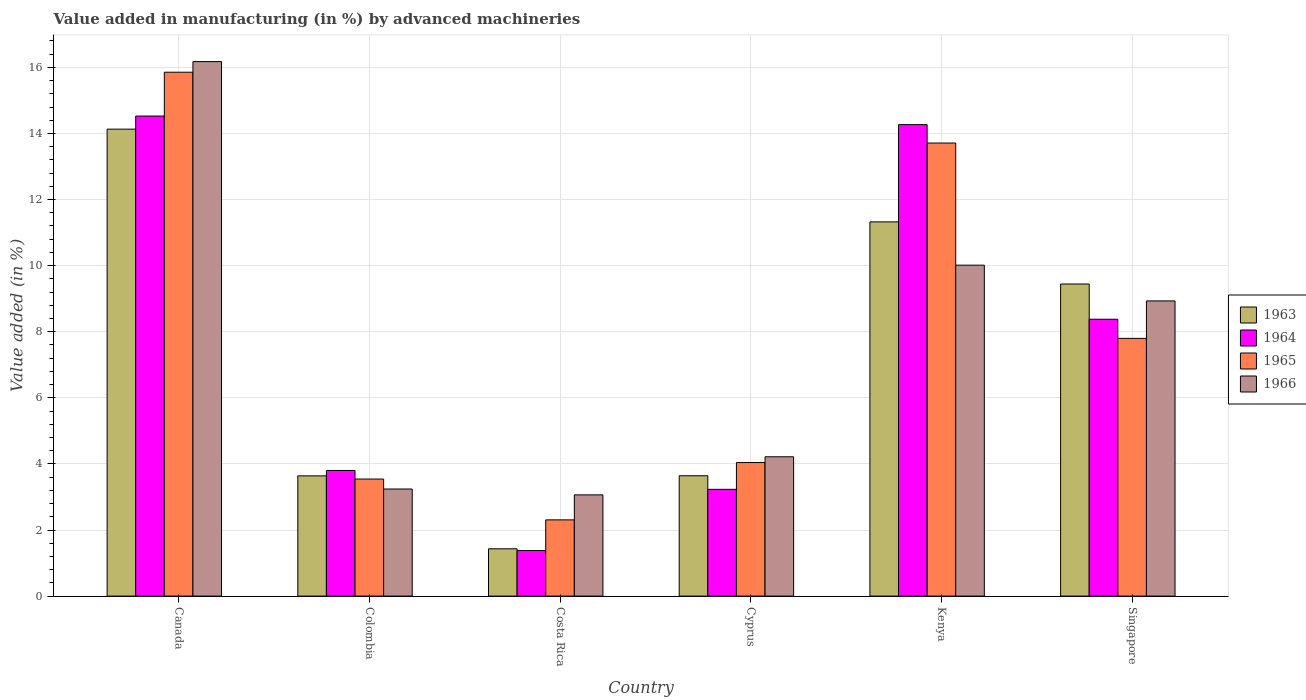How many groups of bars are there?
Offer a terse response. 6. Are the number of bars on each tick of the X-axis equal?
Make the answer very short. Yes. What is the label of the 5th group of bars from the left?
Keep it short and to the point. Kenya. In how many cases, is the number of bars for a given country not equal to the number of legend labels?
Your answer should be compact. 0. What is the percentage of value added in manufacturing by advanced machineries in 1963 in Canada?
Provide a succinct answer. 14.13. Across all countries, what is the maximum percentage of value added in manufacturing by advanced machineries in 1964?
Ensure brevity in your answer.  14.53. Across all countries, what is the minimum percentage of value added in manufacturing by advanced machineries in 1963?
Give a very brief answer. 1.43. In which country was the percentage of value added in manufacturing by advanced machineries in 1966 maximum?
Your response must be concise. Canada. In which country was the percentage of value added in manufacturing by advanced machineries in 1964 minimum?
Your answer should be compact. Costa Rica. What is the total percentage of value added in manufacturing by advanced machineries in 1965 in the graph?
Offer a terse response. 47.25. What is the difference between the percentage of value added in manufacturing by advanced machineries in 1966 in Colombia and that in Cyprus?
Ensure brevity in your answer.  -0.97. What is the difference between the percentage of value added in manufacturing by advanced machineries in 1963 in Singapore and the percentage of value added in manufacturing by advanced machineries in 1964 in Colombia?
Keep it short and to the point. 5.64. What is the average percentage of value added in manufacturing by advanced machineries in 1965 per country?
Make the answer very short. 7.88. What is the difference between the percentage of value added in manufacturing by advanced machineries of/in 1965 and percentage of value added in manufacturing by advanced machineries of/in 1964 in Costa Rica?
Ensure brevity in your answer.  0.93. What is the ratio of the percentage of value added in manufacturing by advanced machineries in 1963 in Costa Rica to that in Cyprus?
Your response must be concise. 0.39. What is the difference between the highest and the second highest percentage of value added in manufacturing by advanced machineries in 1966?
Provide a short and direct response. 7.24. What is the difference between the highest and the lowest percentage of value added in manufacturing by advanced machineries in 1966?
Your answer should be compact. 13.11. In how many countries, is the percentage of value added in manufacturing by advanced machineries in 1964 greater than the average percentage of value added in manufacturing by advanced machineries in 1964 taken over all countries?
Your answer should be compact. 3. Is the sum of the percentage of value added in manufacturing by advanced machineries in 1965 in Colombia and Kenya greater than the maximum percentage of value added in manufacturing by advanced machineries in 1963 across all countries?
Ensure brevity in your answer.  Yes. What does the 4th bar from the left in Singapore represents?
Offer a terse response. 1966. What does the 2nd bar from the right in Colombia represents?
Your answer should be very brief. 1965. Is it the case that in every country, the sum of the percentage of value added in manufacturing by advanced machineries in 1963 and percentage of value added in manufacturing by advanced machineries in 1966 is greater than the percentage of value added in manufacturing by advanced machineries in 1965?
Make the answer very short. Yes. How many bars are there?
Make the answer very short. 24. How many countries are there in the graph?
Offer a terse response. 6. Does the graph contain any zero values?
Ensure brevity in your answer.  No. Does the graph contain grids?
Offer a terse response. Yes. How many legend labels are there?
Make the answer very short. 4. What is the title of the graph?
Provide a short and direct response. Value added in manufacturing (in %) by advanced machineries. Does "1972" appear as one of the legend labels in the graph?
Offer a very short reply. No. What is the label or title of the X-axis?
Make the answer very short. Country. What is the label or title of the Y-axis?
Ensure brevity in your answer.  Value added (in %). What is the Value added (in %) of 1963 in Canada?
Provide a short and direct response. 14.13. What is the Value added (in %) in 1964 in Canada?
Your response must be concise. 14.53. What is the Value added (in %) of 1965 in Canada?
Offer a very short reply. 15.85. What is the Value added (in %) in 1966 in Canada?
Give a very brief answer. 16.17. What is the Value added (in %) of 1963 in Colombia?
Your answer should be very brief. 3.64. What is the Value added (in %) in 1964 in Colombia?
Keep it short and to the point. 3.8. What is the Value added (in %) in 1965 in Colombia?
Keep it short and to the point. 3.54. What is the Value added (in %) of 1966 in Colombia?
Your response must be concise. 3.24. What is the Value added (in %) of 1963 in Costa Rica?
Make the answer very short. 1.43. What is the Value added (in %) in 1964 in Costa Rica?
Keep it short and to the point. 1.38. What is the Value added (in %) in 1965 in Costa Rica?
Make the answer very short. 2.31. What is the Value added (in %) in 1966 in Costa Rica?
Ensure brevity in your answer.  3.06. What is the Value added (in %) in 1963 in Cyprus?
Offer a terse response. 3.64. What is the Value added (in %) in 1964 in Cyprus?
Keep it short and to the point. 3.23. What is the Value added (in %) in 1965 in Cyprus?
Make the answer very short. 4.04. What is the Value added (in %) in 1966 in Cyprus?
Keep it short and to the point. 4.22. What is the Value added (in %) in 1963 in Kenya?
Ensure brevity in your answer.  11.32. What is the Value added (in %) in 1964 in Kenya?
Provide a succinct answer. 14.27. What is the Value added (in %) of 1965 in Kenya?
Offer a terse response. 13.71. What is the Value added (in %) of 1966 in Kenya?
Give a very brief answer. 10.01. What is the Value added (in %) in 1963 in Singapore?
Your answer should be very brief. 9.44. What is the Value added (in %) in 1964 in Singapore?
Keep it short and to the point. 8.38. What is the Value added (in %) in 1965 in Singapore?
Provide a short and direct response. 7.8. What is the Value added (in %) of 1966 in Singapore?
Your response must be concise. 8.93. Across all countries, what is the maximum Value added (in %) in 1963?
Ensure brevity in your answer.  14.13. Across all countries, what is the maximum Value added (in %) of 1964?
Your answer should be very brief. 14.53. Across all countries, what is the maximum Value added (in %) in 1965?
Your response must be concise. 15.85. Across all countries, what is the maximum Value added (in %) in 1966?
Provide a succinct answer. 16.17. Across all countries, what is the minimum Value added (in %) in 1963?
Your answer should be compact. 1.43. Across all countries, what is the minimum Value added (in %) of 1964?
Your answer should be compact. 1.38. Across all countries, what is the minimum Value added (in %) in 1965?
Make the answer very short. 2.31. Across all countries, what is the minimum Value added (in %) in 1966?
Your answer should be compact. 3.06. What is the total Value added (in %) of 1963 in the graph?
Keep it short and to the point. 43.61. What is the total Value added (in %) in 1964 in the graph?
Offer a very short reply. 45.58. What is the total Value added (in %) of 1965 in the graph?
Keep it short and to the point. 47.25. What is the total Value added (in %) of 1966 in the graph?
Your answer should be very brief. 45.64. What is the difference between the Value added (in %) of 1963 in Canada and that in Colombia?
Keep it short and to the point. 10.49. What is the difference between the Value added (in %) of 1964 in Canada and that in Colombia?
Make the answer very short. 10.72. What is the difference between the Value added (in %) in 1965 in Canada and that in Colombia?
Your answer should be compact. 12.31. What is the difference between the Value added (in %) of 1966 in Canada and that in Colombia?
Provide a succinct answer. 12.93. What is the difference between the Value added (in %) of 1963 in Canada and that in Costa Rica?
Give a very brief answer. 12.7. What is the difference between the Value added (in %) in 1964 in Canada and that in Costa Rica?
Provide a succinct answer. 13.15. What is the difference between the Value added (in %) of 1965 in Canada and that in Costa Rica?
Your answer should be very brief. 13.55. What is the difference between the Value added (in %) of 1966 in Canada and that in Costa Rica?
Make the answer very short. 13.11. What is the difference between the Value added (in %) in 1963 in Canada and that in Cyprus?
Your answer should be very brief. 10.49. What is the difference between the Value added (in %) of 1964 in Canada and that in Cyprus?
Offer a very short reply. 11.3. What is the difference between the Value added (in %) in 1965 in Canada and that in Cyprus?
Your answer should be very brief. 11.81. What is the difference between the Value added (in %) in 1966 in Canada and that in Cyprus?
Give a very brief answer. 11.96. What is the difference between the Value added (in %) in 1963 in Canada and that in Kenya?
Ensure brevity in your answer.  2.81. What is the difference between the Value added (in %) in 1964 in Canada and that in Kenya?
Provide a succinct answer. 0.26. What is the difference between the Value added (in %) in 1965 in Canada and that in Kenya?
Offer a terse response. 2.14. What is the difference between the Value added (in %) in 1966 in Canada and that in Kenya?
Keep it short and to the point. 6.16. What is the difference between the Value added (in %) in 1963 in Canada and that in Singapore?
Your answer should be very brief. 4.69. What is the difference between the Value added (in %) of 1964 in Canada and that in Singapore?
Make the answer very short. 6.15. What is the difference between the Value added (in %) in 1965 in Canada and that in Singapore?
Make the answer very short. 8.05. What is the difference between the Value added (in %) of 1966 in Canada and that in Singapore?
Your answer should be very brief. 7.24. What is the difference between the Value added (in %) in 1963 in Colombia and that in Costa Rica?
Your response must be concise. 2.21. What is the difference between the Value added (in %) of 1964 in Colombia and that in Costa Rica?
Ensure brevity in your answer.  2.42. What is the difference between the Value added (in %) of 1965 in Colombia and that in Costa Rica?
Your answer should be compact. 1.24. What is the difference between the Value added (in %) of 1966 in Colombia and that in Costa Rica?
Give a very brief answer. 0.18. What is the difference between the Value added (in %) of 1963 in Colombia and that in Cyprus?
Make the answer very short. -0. What is the difference between the Value added (in %) in 1964 in Colombia and that in Cyprus?
Offer a terse response. 0.57. What is the difference between the Value added (in %) of 1965 in Colombia and that in Cyprus?
Provide a succinct answer. -0.5. What is the difference between the Value added (in %) in 1966 in Colombia and that in Cyprus?
Provide a succinct answer. -0.97. What is the difference between the Value added (in %) in 1963 in Colombia and that in Kenya?
Give a very brief answer. -7.69. What is the difference between the Value added (in %) of 1964 in Colombia and that in Kenya?
Give a very brief answer. -10.47. What is the difference between the Value added (in %) of 1965 in Colombia and that in Kenya?
Offer a terse response. -10.17. What is the difference between the Value added (in %) in 1966 in Colombia and that in Kenya?
Your response must be concise. -6.77. What is the difference between the Value added (in %) of 1963 in Colombia and that in Singapore?
Provide a succinct answer. -5.81. What is the difference between the Value added (in %) of 1964 in Colombia and that in Singapore?
Keep it short and to the point. -4.58. What is the difference between the Value added (in %) of 1965 in Colombia and that in Singapore?
Make the answer very short. -4.26. What is the difference between the Value added (in %) of 1966 in Colombia and that in Singapore?
Provide a short and direct response. -5.69. What is the difference between the Value added (in %) of 1963 in Costa Rica and that in Cyprus?
Make the answer very short. -2.21. What is the difference between the Value added (in %) in 1964 in Costa Rica and that in Cyprus?
Give a very brief answer. -1.85. What is the difference between the Value added (in %) in 1965 in Costa Rica and that in Cyprus?
Your answer should be compact. -1.73. What is the difference between the Value added (in %) of 1966 in Costa Rica and that in Cyprus?
Give a very brief answer. -1.15. What is the difference between the Value added (in %) of 1963 in Costa Rica and that in Kenya?
Ensure brevity in your answer.  -9.89. What is the difference between the Value added (in %) in 1964 in Costa Rica and that in Kenya?
Offer a terse response. -12.89. What is the difference between the Value added (in %) of 1965 in Costa Rica and that in Kenya?
Offer a terse response. -11.4. What is the difference between the Value added (in %) of 1966 in Costa Rica and that in Kenya?
Your answer should be compact. -6.95. What is the difference between the Value added (in %) in 1963 in Costa Rica and that in Singapore?
Keep it short and to the point. -8.01. What is the difference between the Value added (in %) of 1964 in Costa Rica and that in Singapore?
Make the answer very short. -7. What is the difference between the Value added (in %) of 1965 in Costa Rica and that in Singapore?
Your answer should be compact. -5.49. What is the difference between the Value added (in %) of 1966 in Costa Rica and that in Singapore?
Offer a terse response. -5.87. What is the difference between the Value added (in %) of 1963 in Cyprus and that in Kenya?
Make the answer very short. -7.68. What is the difference between the Value added (in %) of 1964 in Cyprus and that in Kenya?
Give a very brief answer. -11.04. What is the difference between the Value added (in %) of 1965 in Cyprus and that in Kenya?
Keep it short and to the point. -9.67. What is the difference between the Value added (in %) of 1966 in Cyprus and that in Kenya?
Keep it short and to the point. -5.8. What is the difference between the Value added (in %) in 1963 in Cyprus and that in Singapore?
Offer a very short reply. -5.8. What is the difference between the Value added (in %) of 1964 in Cyprus and that in Singapore?
Ensure brevity in your answer.  -5.15. What is the difference between the Value added (in %) of 1965 in Cyprus and that in Singapore?
Your response must be concise. -3.76. What is the difference between the Value added (in %) of 1966 in Cyprus and that in Singapore?
Provide a short and direct response. -4.72. What is the difference between the Value added (in %) of 1963 in Kenya and that in Singapore?
Your response must be concise. 1.88. What is the difference between the Value added (in %) of 1964 in Kenya and that in Singapore?
Give a very brief answer. 5.89. What is the difference between the Value added (in %) in 1965 in Kenya and that in Singapore?
Give a very brief answer. 5.91. What is the difference between the Value added (in %) in 1966 in Kenya and that in Singapore?
Make the answer very short. 1.08. What is the difference between the Value added (in %) in 1963 in Canada and the Value added (in %) in 1964 in Colombia?
Offer a terse response. 10.33. What is the difference between the Value added (in %) of 1963 in Canada and the Value added (in %) of 1965 in Colombia?
Make the answer very short. 10.59. What is the difference between the Value added (in %) of 1963 in Canada and the Value added (in %) of 1966 in Colombia?
Provide a succinct answer. 10.89. What is the difference between the Value added (in %) of 1964 in Canada and the Value added (in %) of 1965 in Colombia?
Keep it short and to the point. 10.98. What is the difference between the Value added (in %) of 1964 in Canada and the Value added (in %) of 1966 in Colombia?
Your answer should be very brief. 11.29. What is the difference between the Value added (in %) of 1965 in Canada and the Value added (in %) of 1966 in Colombia?
Your answer should be very brief. 12.61. What is the difference between the Value added (in %) of 1963 in Canada and the Value added (in %) of 1964 in Costa Rica?
Ensure brevity in your answer.  12.75. What is the difference between the Value added (in %) of 1963 in Canada and the Value added (in %) of 1965 in Costa Rica?
Give a very brief answer. 11.82. What is the difference between the Value added (in %) of 1963 in Canada and the Value added (in %) of 1966 in Costa Rica?
Give a very brief answer. 11.07. What is the difference between the Value added (in %) in 1964 in Canada and the Value added (in %) in 1965 in Costa Rica?
Keep it short and to the point. 12.22. What is the difference between the Value added (in %) of 1964 in Canada and the Value added (in %) of 1966 in Costa Rica?
Keep it short and to the point. 11.46. What is the difference between the Value added (in %) of 1965 in Canada and the Value added (in %) of 1966 in Costa Rica?
Make the answer very short. 12.79. What is the difference between the Value added (in %) of 1963 in Canada and the Value added (in %) of 1964 in Cyprus?
Your answer should be very brief. 10.9. What is the difference between the Value added (in %) in 1963 in Canada and the Value added (in %) in 1965 in Cyprus?
Give a very brief answer. 10.09. What is the difference between the Value added (in %) in 1963 in Canada and the Value added (in %) in 1966 in Cyprus?
Make the answer very short. 9.92. What is the difference between the Value added (in %) of 1964 in Canada and the Value added (in %) of 1965 in Cyprus?
Provide a short and direct response. 10.49. What is the difference between the Value added (in %) of 1964 in Canada and the Value added (in %) of 1966 in Cyprus?
Provide a short and direct response. 10.31. What is the difference between the Value added (in %) in 1965 in Canada and the Value added (in %) in 1966 in Cyprus?
Provide a short and direct response. 11.64. What is the difference between the Value added (in %) in 1963 in Canada and the Value added (in %) in 1964 in Kenya?
Ensure brevity in your answer.  -0.14. What is the difference between the Value added (in %) of 1963 in Canada and the Value added (in %) of 1965 in Kenya?
Provide a short and direct response. 0.42. What is the difference between the Value added (in %) in 1963 in Canada and the Value added (in %) in 1966 in Kenya?
Keep it short and to the point. 4.12. What is the difference between the Value added (in %) of 1964 in Canada and the Value added (in %) of 1965 in Kenya?
Ensure brevity in your answer.  0.82. What is the difference between the Value added (in %) in 1964 in Canada and the Value added (in %) in 1966 in Kenya?
Your response must be concise. 4.51. What is the difference between the Value added (in %) of 1965 in Canada and the Value added (in %) of 1966 in Kenya?
Offer a very short reply. 5.84. What is the difference between the Value added (in %) of 1963 in Canada and the Value added (in %) of 1964 in Singapore?
Make the answer very short. 5.75. What is the difference between the Value added (in %) in 1963 in Canada and the Value added (in %) in 1965 in Singapore?
Keep it short and to the point. 6.33. What is the difference between the Value added (in %) of 1963 in Canada and the Value added (in %) of 1966 in Singapore?
Your answer should be very brief. 5.2. What is the difference between the Value added (in %) in 1964 in Canada and the Value added (in %) in 1965 in Singapore?
Provide a succinct answer. 6.73. What is the difference between the Value added (in %) in 1964 in Canada and the Value added (in %) in 1966 in Singapore?
Your answer should be very brief. 5.59. What is the difference between the Value added (in %) of 1965 in Canada and the Value added (in %) of 1966 in Singapore?
Your response must be concise. 6.92. What is the difference between the Value added (in %) in 1963 in Colombia and the Value added (in %) in 1964 in Costa Rica?
Provide a short and direct response. 2.26. What is the difference between the Value added (in %) of 1963 in Colombia and the Value added (in %) of 1965 in Costa Rica?
Provide a succinct answer. 1.33. What is the difference between the Value added (in %) of 1963 in Colombia and the Value added (in %) of 1966 in Costa Rica?
Your answer should be compact. 0.57. What is the difference between the Value added (in %) in 1964 in Colombia and the Value added (in %) in 1965 in Costa Rica?
Ensure brevity in your answer.  1.49. What is the difference between the Value added (in %) of 1964 in Colombia and the Value added (in %) of 1966 in Costa Rica?
Your response must be concise. 0.74. What is the difference between the Value added (in %) in 1965 in Colombia and the Value added (in %) in 1966 in Costa Rica?
Offer a very short reply. 0.48. What is the difference between the Value added (in %) in 1963 in Colombia and the Value added (in %) in 1964 in Cyprus?
Provide a succinct answer. 0.41. What is the difference between the Value added (in %) of 1963 in Colombia and the Value added (in %) of 1965 in Cyprus?
Provide a short and direct response. -0.4. What is the difference between the Value added (in %) in 1963 in Colombia and the Value added (in %) in 1966 in Cyprus?
Your answer should be compact. -0.58. What is the difference between the Value added (in %) of 1964 in Colombia and the Value added (in %) of 1965 in Cyprus?
Your answer should be very brief. -0.24. What is the difference between the Value added (in %) in 1964 in Colombia and the Value added (in %) in 1966 in Cyprus?
Provide a succinct answer. -0.41. What is the difference between the Value added (in %) in 1965 in Colombia and the Value added (in %) in 1966 in Cyprus?
Your answer should be compact. -0.67. What is the difference between the Value added (in %) of 1963 in Colombia and the Value added (in %) of 1964 in Kenya?
Your response must be concise. -10.63. What is the difference between the Value added (in %) in 1963 in Colombia and the Value added (in %) in 1965 in Kenya?
Provide a short and direct response. -10.07. What is the difference between the Value added (in %) in 1963 in Colombia and the Value added (in %) in 1966 in Kenya?
Keep it short and to the point. -6.38. What is the difference between the Value added (in %) of 1964 in Colombia and the Value added (in %) of 1965 in Kenya?
Make the answer very short. -9.91. What is the difference between the Value added (in %) in 1964 in Colombia and the Value added (in %) in 1966 in Kenya?
Provide a succinct answer. -6.21. What is the difference between the Value added (in %) in 1965 in Colombia and the Value added (in %) in 1966 in Kenya?
Offer a very short reply. -6.47. What is the difference between the Value added (in %) of 1963 in Colombia and the Value added (in %) of 1964 in Singapore?
Give a very brief answer. -4.74. What is the difference between the Value added (in %) of 1963 in Colombia and the Value added (in %) of 1965 in Singapore?
Your response must be concise. -4.16. What is the difference between the Value added (in %) in 1963 in Colombia and the Value added (in %) in 1966 in Singapore?
Provide a short and direct response. -5.29. What is the difference between the Value added (in %) of 1964 in Colombia and the Value added (in %) of 1965 in Singapore?
Give a very brief answer. -4. What is the difference between the Value added (in %) in 1964 in Colombia and the Value added (in %) in 1966 in Singapore?
Provide a short and direct response. -5.13. What is the difference between the Value added (in %) of 1965 in Colombia and the Value added (in %) of 1966 in Singapore?
Your answer should be compact. -5.39. What is the difference between the Value added (in %) of 1963 in Costa Rica and the Value added (in %) of 1964 in Cyprus?
Provide a short and direct response. -1.8. What is the difference between the Value added (in %) in 1963 in Costa Rica and the Value added (in %) in 1965 in Cyprus?
Provide a short and direct response. -2.61. What is the difference between the Value added (in %) of 1963 in Costa Rica and the Value added (in %) of 1966 in Cyprus?
Ensure brevity in your answer.  -2.78. What is the difference between the Value added (in %) of 1964 in Costa Rica and the Value added (in %) of 1965 in Cyprus?
Offer a terse response. -2.66. What is the difference between the Value added (in %) in 1964 in Costa Rica and the Value added (in %) in 1966 in Cyprus?
Keep it short and to the point. -2.84. What is the difference between the Value added (in %) of 1965 in Costa Rica and the Value added (in %) of 1966 in Cyprus?
Keep it short and to the point. -1.91. What is the difference between the Value added (in %) in 1963 in Costa Rica and the Value added (in %) in 1964 in Kenya?
Offer a very short reply. -12.84. What is the difference between the Value added (in %) in 1963 in Costa Rica and the Value added (in %) in 1965 in Kenya?
Ensure brevity in your answer.  -12.28. What is the difference between the Value added (in %) of 1963 in Costa Rica and the Value added (in %) of 1966 in Kenya?
Provide a short and direct response. -8.58. What is the difference between the Value added (in %) of 1964 in Costa Rica and the Value added (in %) of 1965 in Kenya?
Your response must be concise. -12.33. What is the difference between the Value added (in %) in 1964 in Costa Rica and the Value added (in %) in 1966 in Kenya?
Provide a succinct answer. -8.64. What is the difference between the Value added (in %) of 1965 in Costa Rica and the Value added (in %) of 1966 in Kenya?
Offer a terse response. -7.71. What is the difference between the Value added (in %) in 1963 in Costa Rica and the Value added (in %) in 1964 in Singapore?
Provide a succinct answer. -6.95. What is the difference between the Value added (in %) in 1963 in Costa Rica and the Value added (in %) in 1965 in Singapore?
Provide a short and direct response. -6.37. What is the difference between the Value added (in %) in 1963 in Costa Rica and the Value added (in %) in 1966 in Singapore?
Offer a terse response. -7.5. What is the difference between the Value added (in %) of 1964 in Costa Rica and the Value added (in %) of 1965 in Singapore?
Keep it short and to the point. -6.42. What is the difference between the Value added (in %) in 1964 in Costa Rica and the Value added (in %) in 1966 in Singapore?
Provide a short and direct response. -7.55. What is the difference between the Value added (in %) in 1965 in Costa Rica and the Value added (in %) in 1966 in Singapore?
Keep it short and to the point. -6.63. What is the difference between the Value added (in %) of 1963 in Cyprus and the Value added (in %) of 1964 in Kenya?
Your response must be concise. -10.63. What is the difference between the Value added (in %) of 1963 in Cyprus and the Value added (in %) of 1965 in Kenya?
Your response must be concise. -10.07. What is the difference between the Value added (in %) of 1963 in Cyprus and the Value added (in %) of 1966 in Kenya?
Your answer should be compact. -6.37. What is the difference between the Value added (in %) of 1964 in Cyprus and the Value added (in %) of 1965 in Kenya?
Your response must be concise. -10.48. What is the difference between the Value added (in %) of 1964 in Cyprus and the Value added (in %) of 1966 in Kenya?
Offer a very short reply. -6.78. What is the difference between the Value added (in %) in 1965 in Cyprus and the Value added (in %) in 1966 in Kenya?
Your answer should be very brief. -5.97. What is the difference between the Value added (in %) of 1963 in Cyprus and the Value added (in %) of 1964 in Singapore?
Keep it short and to the point. -4.74. What is the difference between the Value added (in %) in 1963 in Cyprus and the Value added (in %) in 1965 in Singapore?
Ensure brevity in your answer.  -4.16. What is the difference between the Value added (in %) of 1963 in Cyprus and the Value added (in %) of 1966 in Singapore?
Offer a terse response. -5.29. What is the difference between the Value added (in %) of 1964 in Cyprus and the Value added (in %) of 1965 in Singapore?
Keep it short and to the point. -4.57. What is the difference between the Value added (in %) of 1964 in Cyprus and the Value added (in %) of 1966 in Singapore?
Provide a succinct answer. -5.7. What is the difference between the Value added (in %) of 1965 in Cyprus and the Value added (in %) of 1966 in Singapore?
Your answer should be very brief. -4.89. What is the difference between the Value added (in %) of 1963 in Kenya and the Value added (in %) of 1964 in Singapore?
Your answer should be compact. 2.95. What is the difference between the Value added (in %) of 1963 in Kenya and the Value added (in %) of 1965 in Singapore?
Keep it short and to the point. 3.52. What is the difference between the Value added (in %) of 1963 in Kenya and the Value added (in %) of 1966 in Singapore?
Ensure brevity in your answer.  2.39. What is the difference between the Value added (in %) of 1964 in Kenya and the Value added (in %) of 1965 in Singapore?
Your answer should be very brief. 6.47. What is the difference between the Value added (in %) of 1964 in Kenya and the Value added (in %) of 1966 in Singapore?
Make the answer very short. 5.33. What is the difference between the Value added (in %) in 1965 in Kenya and the Value added (in %) in 1966 in Singapore?
Your response must be concise. 4.78. What is the average Value added (in %) of 1963 per country?
Provide a short and direct response. 7.27. What is the average Value added (in %) in 1964 per country?
Give a very brief answer. 7.6. What is the average Value added (in %) in 1965 per country?
Make the answer very short. 7.88. What is the average Value added (in %) of 1966 per country?
Keep it short and to the point. 7.61. What is the difference between the Value added (in %) of 1963 and Value added (in %) of 1964 in Canada?
Provide a succinct answer. -0.4. What is the difference between the Value added (in %) in 1963 and Value added (in %) in 1965 in Canada?
Your answer should be very brief. -1.72. What is the difference between the Value added (in %) in 1963 and Value added (in %) in 1966 in Canada?
Your answer should be very brief. -2.04. What is the difference between the Value added (in %) in 1964 and Value added (in %) in 1965 in Canada?
Make the answer very short. -1.33. What is the difference between the Value added (in %) of 1964 and Value added (in %) of 1966 in Canada?
Your answer should be compact. -1.65. What is the difference between the Value added (in %) of 1965 and Value added (in %) of 1966 in Canada?
Your answer should be very brief. -0.32. What is the difference between the Value added (in %) in 1963 and Value added (in %) in 1964 in Colombia?
Offer a terse response. -0.16. What is the difference between the Value added (in %) of 1963 and Value added (in %) of 1965 in Colombia?
Give a very brief answer. 0.1. What is the difference between the Value added (in %) of 1963 and Value added (in %) of 1966 in Colombia?
Keep it short and to the point. 0.4. What is the difference between the Value added (in %) of 1964 and Value added (in %) of 1965 in Colombia?
Your response must be concise. 0.26. What is the difference between the Value added (in %) of 1964 and Value added (in %) of 1966 in Colombia?
Your response must be concise. 0.56. What is the difference between the Value added (in %) in 1965 and Value added (in %) in 1966 in Colombia?
Offer a terse response. 0.3. What is the difference between the Value added (in %) in 1963 and Value added (in %) in 1964 in Costa Rica?
Provide a succinct answer. 0.05. What is the difference between the Value added (in %) of 1963 and Value added (in %) of 1965 in Costa Rica?
Offer a very short reply. -0.88. What is the difference between the Value added (in %) in 1963 and Value added (in %) in 1966 in Costa Rica?
Ensure brevity in your answer.  -1.63. What is the difference between the Value added (in %) in 1964 and Value added (in %) in 1965 in Costa Rica?
Offer a very short reply. -0.93. What is the difference between the Value added (in %) in 1964 and Value added (in %) in 1966 in Costa Rica?
Your answer should be very brief. -1.69. What is the difference between the Value added (in %) in 1965 and Value added (in %) in 1966 in Costa Rica?
Make the answer very short. -0.76. What is the difference between the Value added (in %) of 1963 and Value added (in %) of 1964 in Cyprus?
Offer a very short reply. 0.41. What is the difference between the Value added (in %) in 1963 and Value added (in %) in 1965 in Cyprus?
Ensure brevity in your answer.  -0.4. What is the difference between the Value added (in %) in 1963 and Value added (in %) in 1966 in Cyprus?
Your answer should be very brief. -0.57. What is the difference between the Value added (in %) of 1964 and Value added (in %) of 1965 in Cyprus?
Offer a terse response. -0.81. What is the difference between the Value added (in %) in 1964 and Value added (in %) in 1966 in Cyprus?
Your answer should be compact. -0.98. What is the difference between the Value added (in %) in 1965 and Value added (in %) in 1966 in Cyprus?
Give a very brief answer. -0.17. What is the difference between the Value added (in %) in 1963 and Value added (in %) in 1964 in Kenya?
Give a very brief answer. -2.94. What is the difference between the Value added (in %) in 1963 and Value added (in %) in 1965 in Kenya?
Your answer should be compact. -2.39. What is the difference between the Value added (in %) of 1963 and Value added (in %) of 1966 in Kenya?
Offer a terse response. 1.31. What is the difference between the Value added (in %) in 1964 and Value added (in %) in 1965 in Kenya?
Ensure brevity in your answer.  0.56. What is the difference between the Value added (in %) of 1964 and Value added (in %) of 1966 in Kenya?
Provide a succinct answer. 4.25. What is the difference between the Value added (in %) of 1965 and Value added (in %) of 1966 in Kenya?
Make the answer very short. 3.7. What is the difference between the Value added (in %) of 1963 and Value added (in %) of 1964 in Singapore?
Your answer should be compact. 1.07. What is the difference between the Value added (in %) in 1963 and Value added (in %) in 1965 in Singapore?
Offer a very short reply. 1.64. What is the difference between the Value added (in %) of 1963 and Value added (in %) of 1966 in Singapore?
Give a very brief answer. 0.51. What is the difference between the Value added (in %) in 1964 and Value added (in %) in 1965 in Singapore?
Keep it short and to the point. 0.58. What is the difference between the Value added (in %) in 1964 and Value added (in %) in 1966 in Singapore?
Make the answer very short. -0.55. What is the difference between the Value added (in %) in 1965 and Value added (in %) in 1966 in Singapore?
Provide a succinct answer. -1.13. What is the ratio of the Value added (in %) of 1963 in Canada to that in Colombia?
Offer a terse response. 3.88. What is the ratio of the Value added (in %) of 1964 in Canada to that in Colombia?
Make the answer very short. 3.82. What is the ratio of the Value added (in %) in 1965 in Canada to that in Colombia?
Your answer should be compact. 4.48. What is the ratio of the Value added (in %) in 1966 in Canada to that in Colombia?
Offer a very short reply. 4.99. What is the ratio of the Value added (in %) of 1963 in Canada to that in Costa Rica?
Your answer should be compact. 9.87. What is the ratio of the Value added (in %) in 1964 in Canada to that in Costa Rica?
Ensure brevity in your answer.  10.54. What is the ratio of the Value added (in %) in 1965 in Canada to that in Costa Rica?
Provide a short and direct response. 6.87. What is the ratio of the Value added (in %) in 1966 in Canada to that in Costa Rica?
Offer a very short reply. 5.28. What is the ratio of the Value added (in %) of 1963 in Canada to that in Cyprus?
Ensure brevity in your answer.  3.88. What is the ratio of the Value added (in %) of 1964 in Canada to that in Cyprus?
Your answer should be compact. 4.5. What is the ratio of the Value added (in %) in 1965 in Canada to that in Cyprus?
Provide a succinct answer. 3.92. What is the ratio of the Value added (in %) in 1966 in Canada to that in Cyprus?
Give a very brief answer. 3.84. What is the ratio of the Value added (in %) in 1963 in Canada to that in Kenya?
Your answer should be compact. 1.25. What is the ratio of the Value added (in %) of 1964 in Canada to that in Kenya?
Provide a succinct answer. 1.02. What is the ratio of the Value added (in %) in 1965 in Canada to that in Kenya?
Provide a short and direct response. 1.16. What is the ratio of the Value added (in %) of 1966 in Canada to that in Kenya?
Make the answer very short. 1.62. What is the ratio of the Value added (in %) in 1963 in Canada to that in Singapore?
Keep it short and to the point. 1.5. What is the ratio of the Value added (in %) in 1964 in Canada to that in Singapore?
Keep it short and to the point. 1.73. What is the ratio of the Value added (in %) of 1965 in Canada to that in Singapore?
Your answer should be very brief. 2.03. What is the ratio of the Value added (in %) of 1966 in Canada to that in Singapore?
Your response must be concise. 1.81. What is the ratio of the Value added (in %) in 1963 in Colombia to that in Costa Rica?
Keep it short and to the point. 2.54. What is the ratio of the Value added (in %) in 1964 in Colombia to that in Costa Rica?
Offer a very short reply. 2.76. What is the ratio of the Value added (in %) of 1965 in Colombia to that in Costa Rica?
Ensure brevity in your answer.  1.54. What is the ratio of the Value added (in %) of 1966 in Colombia to that in Costa Rica?
Your answer should be compact. 1.06. What is the ratio of the Value added (in %) of 1963 in Colombia to that in Cyprus?
Offer a terse response. 1. What is the ratio of the Value added (in %) of 1964 in Colombia to that in Cyprus?
Give a very brief answer. 1.18. What is the ratio of the Value added (in %) in 1965 in Colombia to that in Cyprus?
Provide a succinct answer. 0.88. What is the ratio of the Value added (in %) of 1966 in Colombia to that in Cyprus?
Make the answer very short. 0.77. What is the ratio of the Value added (in %) of 1963 in Colombia to that in Kenya?
Offer a terse response. 0.32. What is the ratio of the Value added (in %) of 1964 in Colombia to that in Kenya?
Your answer should be compact. 0.27. What is the ratio of the Value added (in %) in 1965 in Colombia to that in Kenya?
Offer a very short reply. 0.26. What is the ratio of the Value added (in %) in 1966 in Colombia to that in Kenya?
Offer a very short reply. 0.32. What is the ratio of the Value added (in %) in 1963 in Colombia to that in Singapore?
Provide a succinct answer. 0.39. What is the ratio of the Value added (in %) of 1964 in Colombia to that in Singapore?
Provide a succinct answer. 0.45. What is the ratio of the Value added (in %) of 1965 in Colombia to that in Singapore?
Ensure brevity in your answer.  0.45. What is the ratio of the Value added (in %) in 1966 in Colombia to that in Singapore?
Provide a short and direct response. 0.36. What is the ratio of the Value added (in %) of 1963 in Costa Rica to that in Cyprus?
Make the answer very short. 0.39. What is the ratio of the Value added (in %) in 1964 in Costa Rica to that in Cyprus?
Your response must be concise. 0.43. What is the ratio of the Value added (in %) of 1965 in Costa Rica to that in Cyprus?
Make the answer very short. 0.57. What is the ratio of the Value added (in %) in 1966 in Costa Rica to that in Cyprus?
Your response must be concise. 0.73. What is the ratio of the Value added (in %) in 1963 in Costa Rica to that in Kenya?
Provide a succinct answer. 0.13. What is the ratio of the Value added (in %) in 1964 in Costa Rica to that in Kenya?
Your answer should be compact. 0.1. What is the ratio of the Value added (in %) of 1965 in Costa Rica to that in Kenya?
Your response must be concise. 0.17. What is the ratio of the Value added (in %) in 1966 in Costa Rica to that in Kenya?
Offer a very short reply. 0.31. What is the ratio of the Value added (in %) in 1963 in Costa Rica to that in Singapore?
Give a very brief answer. 0.15. What is the ratio of the Value added (in %) in 1964 in Costa Rica to that in Singapore?
Make the answer very short. 0.16. What is the ratio of the Value added (in %) of 1965 in Costa Rica to that in Singapore?
Provide a short and direct response. 0.3. What is the ratio of the Value added (in %) of 1966 in Costa Rica to that in Singapore?
Offer a terse response. 0.34. What is the ratio of the Value added (in %) in 1963 in Cyprus to that in Kenya?
Offer a very short reply. 0.32. What is the ratio of the Value added (in %) of 1964 in Cyprus to that in Kenya?
Ensure brevity in your answer.  0.23. What is the ratio of the Value added (in %) in 1965 in Cyprus to that in Kenya?
Make the answer very short. 0.29. What is the ratio of the Value added (in %) of 1966 in Cyprus to that in Kenya?
Offer a very short reply. 0.42. What is the ratio of the Value added (in %) in 1963 in Cyprus to that in Singapore?
Your answer should be compact. 0.39. What is the ratio of the Value added (in %) of 1964 in Cyprus to that in Singapore?
Your answer should be very brief. 0.39. What is the ratio of the Value added (in %) of 1965 in Cyprus to that in Singapore?
Provide a short and direct response. 0.52. What is the ratio of the Value added (in %) in 1966 in Cyprus to that in Singapore?
Offer a very short reply. 0.47. What is the ratio of the Value added (in %) of 1963 in Kenya to that in Singapore?
Provide a succinct answer. 1.2. What is the ratio of the Value added (in %) of 1964 in Kenya to that in Singapore?
Provide a short and direct response. 1.7. What is the ratio of the Value added (in %) of 1965 in Kenya to that in Singapore?
Provide a short and direct response. 1.76. What is the ratio of the Value added (in %) of 1966 in Kenya to that in Singapore?
Offer a terse response. 1.12. What is the difference between the highest and the second highest Value added (in %) of 1963?
Provide a succinct answer. 2.81. What is the difference between the highest and the second highest Value added (in %) in 1964?
Offer a very short reply. 0.26. What is the difference between the highest and the second highest Value added (in %) of 1965?
Provide a short and direct response. 2.14. What is the difference between the highest and the second highest Value added (in %) in 1966?
Your answer should be compact. 6.16. What is the difference between the highest and the lowest Value added (in %) in 1963?
Your answer should be compact. 12.7. What is the difference between the highest and the lowest Value added (in %) in 1964?
Ensure brevity in your answer.  13.15. What is the difference between the highest and the lowest Value added (in %) in 1965?
Your answer should be compact. 13.55. What is the difference between the highest and the lowest Value added (in %) of 1966?
Keep it short and to the point. 13.11. 